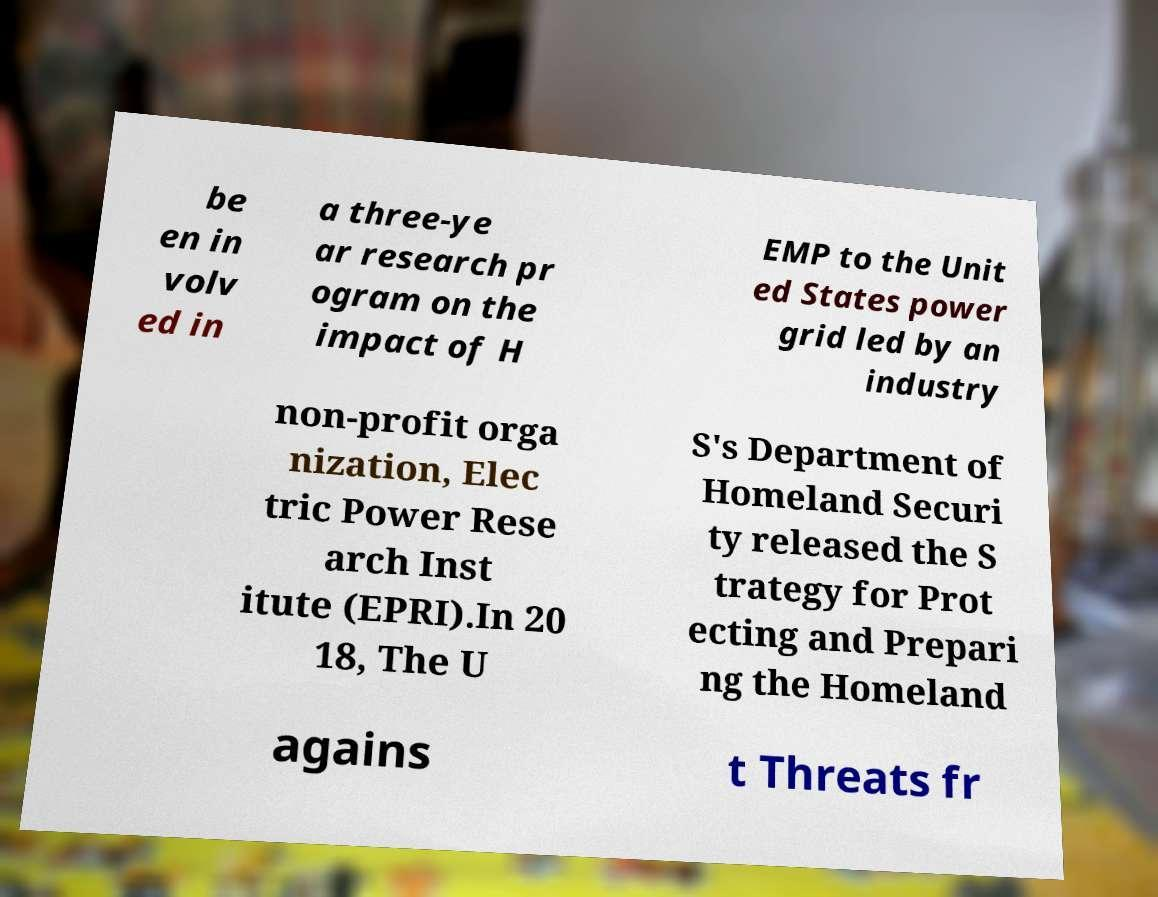Can you read and provide the text displayed in the image?This photo seems to have some interesting text. Can you extract and type it out for me? be en in volv ed in a three-ye ar research pr ogram on the impact of H EMP to the Unit ed States power grid led by an industry non-profit orga nization, Elec tric Power Rese arch Inst itute (EPRI).In 20 18, The U S's Department of Homeland Securi ty released the S trategy for Prot ecting and Prepari ng the Homeland agains t Threats fr 